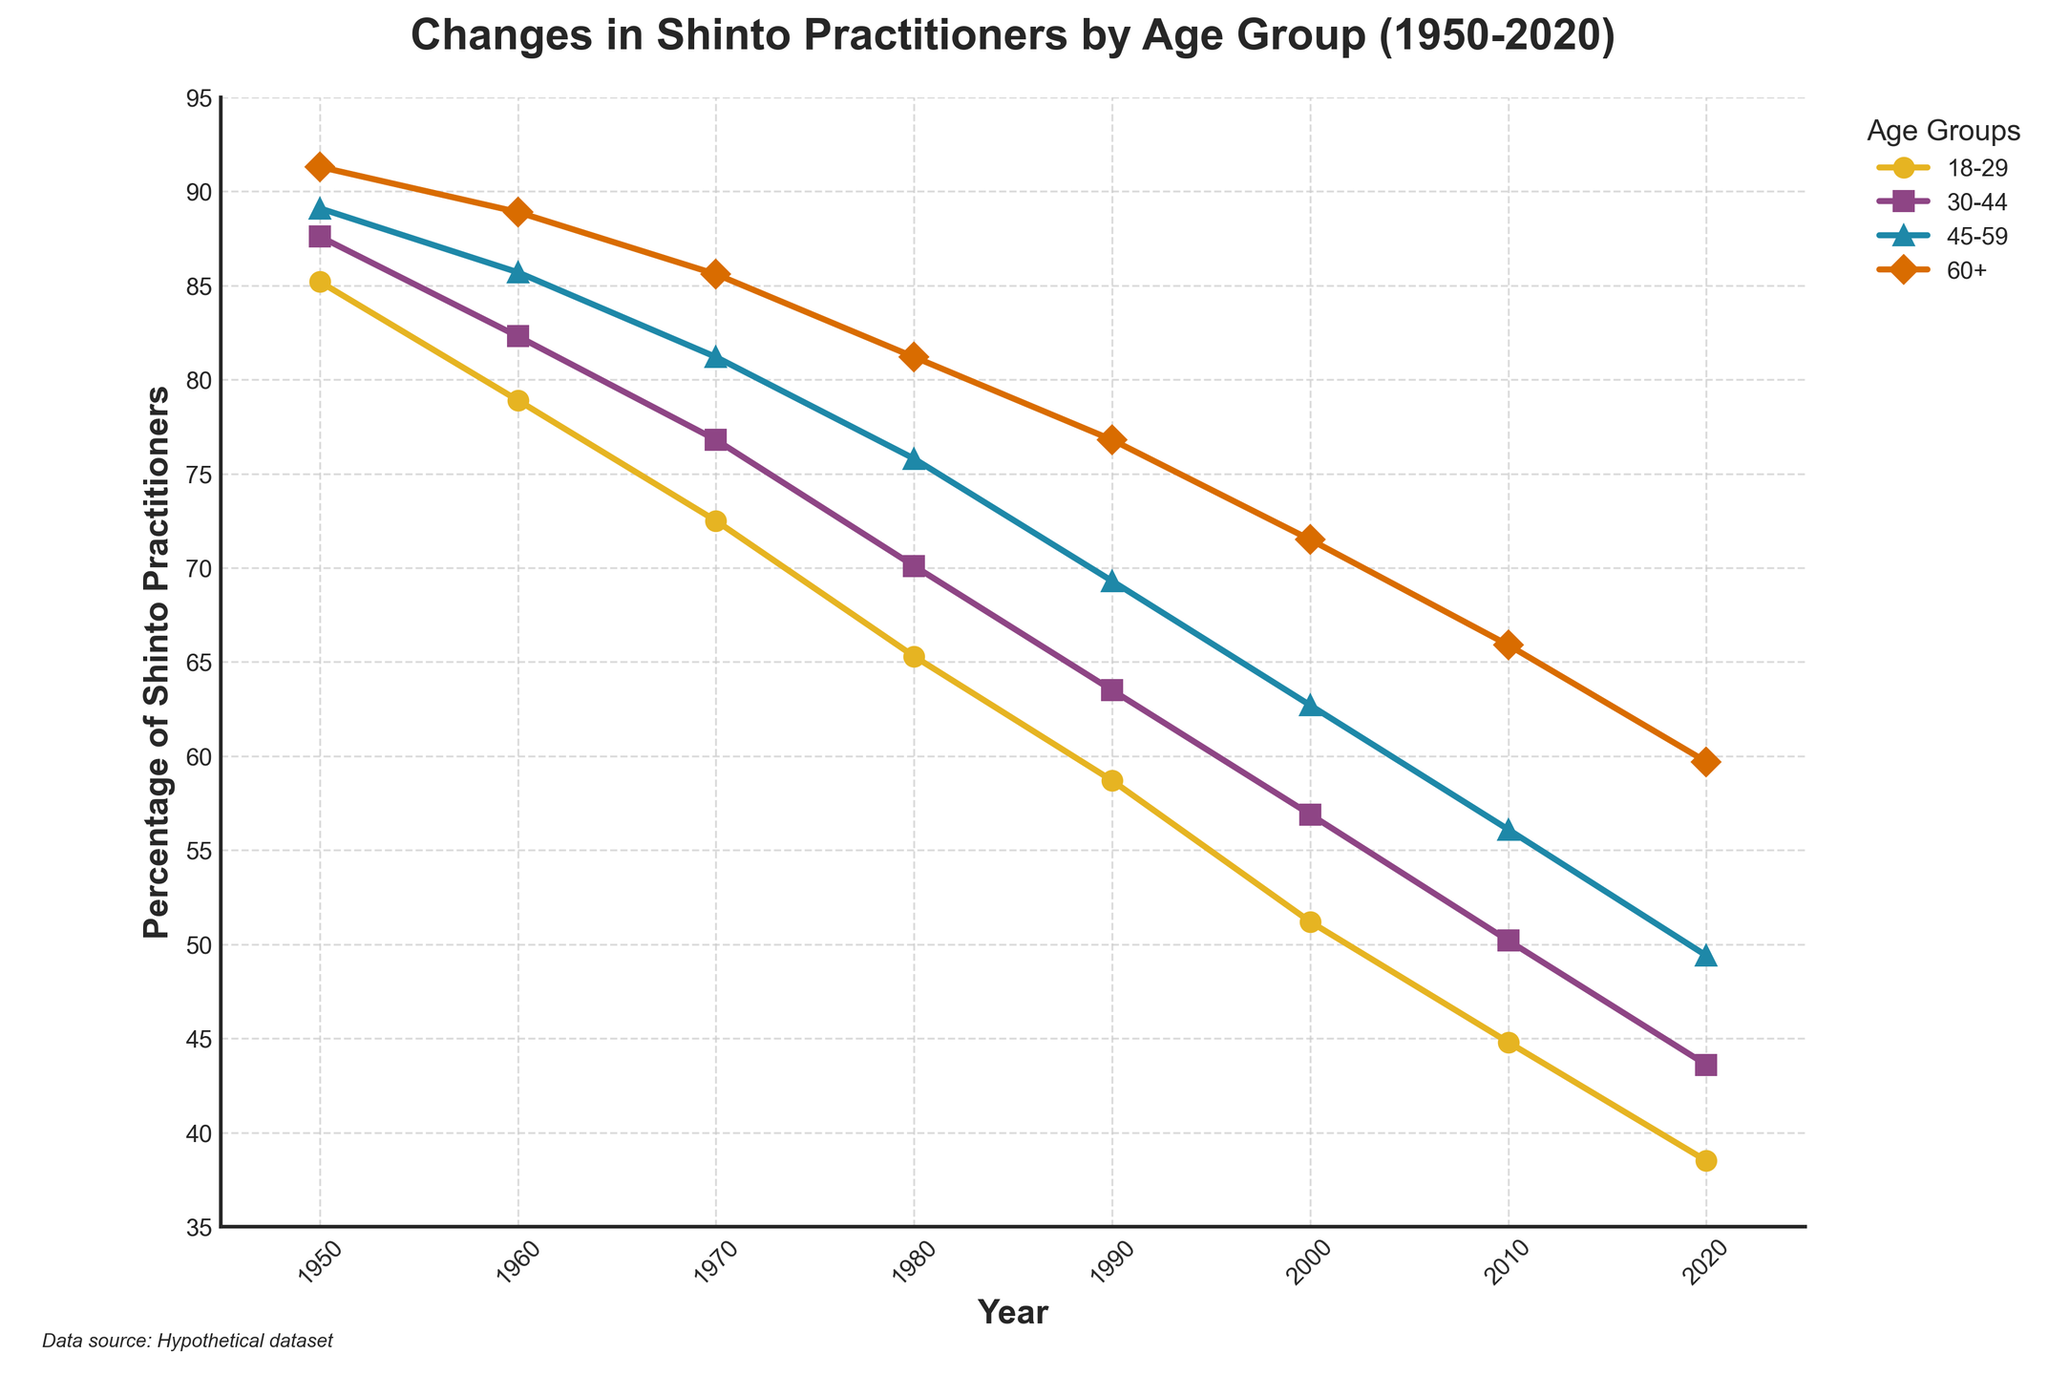What is the percentage drop in Shinto practitioners aged 60+ from 1950 to 2020? To find the percentage drop, subtract the percentage in 2020 from the percentage in 1950: 91.3 - 59.7 = 31.6%
Answer: 31.6% Which age group had the highest percentage of Shinto practitioners in 1980? By looking at the data points in 1980, the age group 60+ had the highest percentage at 81.2%.
Answer: 60+ How does the percentage of Shinto practitioners in the 18-29 age group in 1950 compare to that in 2020? By comparing the values, 85.2% in 1950 and 38.5% in 2020, it's clear that the percentage decreased from 1950 to 2020.
Answer: Decreased In which year did the age group 30-44 have the closest percentage to 50% of Shinto practitioners? Check the data values for the 30-44 age group and find the one closest to 50%. In 2010, the percentage is 50.2%.
Answer: 2010 What is the overall trend in the percentage of Shinto practitioners for the 45-59 age group from 1950 to 2020? Observing the data points from 1950 to 2020, the overall trend is a steady decline from 89.1% to 49.4%.
Answer: Decline How much did the proportion of Shinto practitioners aged 30-44 decrease from 1970 to 2000? Subtract the percentage in 2000 from that in 1970: 76.8 - 56.9 = 19.9%.
Answer: 19.9% Which age group shows the most significant percentage decrease between 1950 and 2020? Calculate the decrease for each group and compare:  
  18-29: 85.2 - 38.5 = 46.7%  
  30-44: 87.6 - 43.6 = 44%  
  45-59: 89.1 - 49.4 = 39.7%  
  60+: 91.3 - 59.7 = 31.6%  
The 18-29 age group shows the most significant decrease at 46.7%.
Answer: 18-29 Which age group experienced the smallest percentage decrease from 1950 to 2020? Calculate the decrease for each group and find the smallest:  
  18-29: 85.2 - 38.5 = 46.7%  
  30-44: 87.6 - 43.6 = 44%  
  45-59: 89.1 - 49.4 = 39.7%  
  60+: 91.3 - 59.7 = 31.6%  
The 60+ age group experienced the smallest decrease at 31.6%.
Answer: 60+ Which color line represents the 18-29 age group in the plot? Refer to the color legend in the plot; the color representing the 18-29 age group is yellow.
Answer: Yellow What is the difference between the percentage of Shinto practitioners aged 30-44 and 60+ in 1990? Subtract the percentage of 60+ from 30-44 in 1990: 76.8 - 63.5 = 13.3%.
Answer: 13.3% 